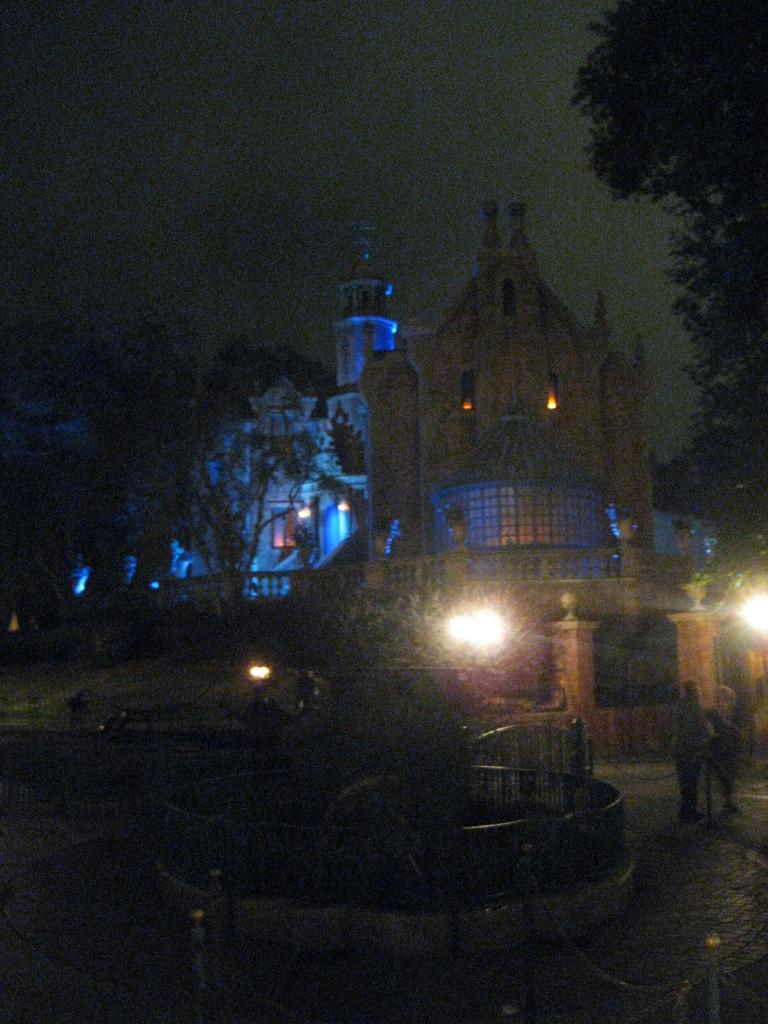What is the overall lighting condition in the image? The image is dark. Can you identify any living beings in the image? Yes, there are people in the image. What other structures or objects can be seen in the image? There are lights, buildings, a fence, trees, and the sky visible in the image. What achievements has the woman in the image accomplished? There is no woman or specific achievements mentioned in the image; it only provides information about the lighting, people, and various structures and objects. 